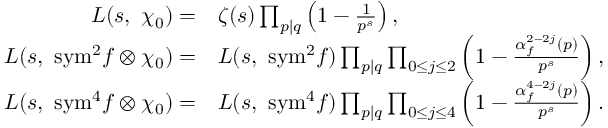<formula> <loc_0><loc_0><loc_500><loc_500>\begin{array} { r l } { L ( s , \ \chi _ { 0 } ) = } & { \zeta ( s ) \prod _ { p | q } \left ( 1 - \frac { 1 } { p ^ { s } } \right ) , } \\ { L ( s , \ { s y m } ^ { 2 } f \otimes \chi _ { 0 } ) = } & { L ( s , \ { s y m ^ { 2 } } f ) \prod _ { p | q } \prod _ { 0 \leq j \leq 2 } \left ( 1 - \frac { \alpha _ { f } ^ { 2 - 2 j } ( p ) } { p ^ { s } } \right ) , } \\ { L ( s , \ { s y m } ^ { 4 } f \otimes \chi _ { 0 } ) = } & { L ( s , \ { s y m ^ { 4 } } f ) \prod _ { p | q } \prod _ { 0 \leq j \leq 4 } \left ( 1 - \frac { \alpha _ { f } ^ { 4 - 2 j } ( p ) } { p ^ { s } } \right ) . } \end{array}</formula> 